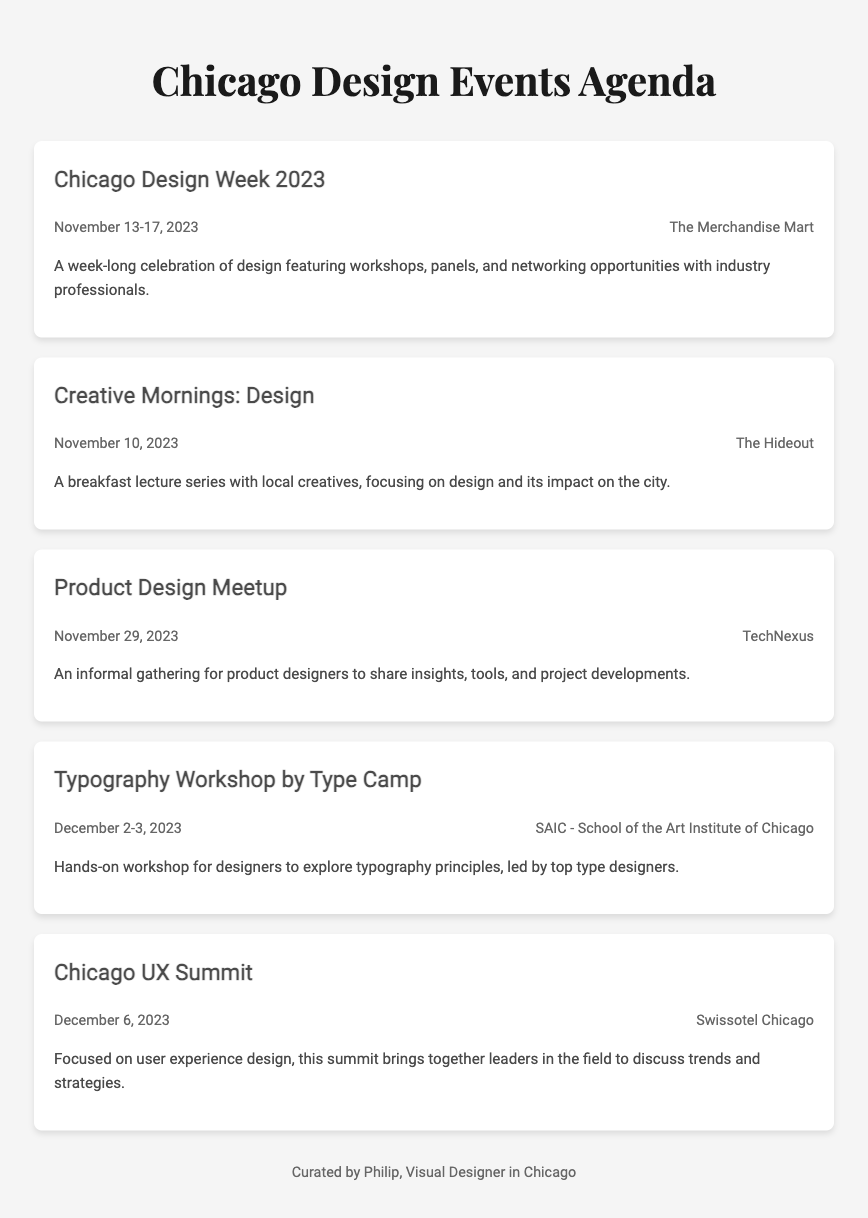What is the date range for Chicago Design Week 2023? Chicago Design Week 2023 occurs from November 13 to November 17, 2023, as stated in the event details.
Answer: November 13-17, 2023 Where is the Typography Workshop by Type Camp held? The venue for the Typography Workshop is mentioned as the School of the Art Institute of Chicago in the event description.
Answer: SAIC - School of the Art Institute of Chicago How many events are listed in the document? The document lists a total of five design events, specifically enumerating them in individual sections.
Answer: 5 What type of event is the Creative Mornings: Design? The event is described as a breakfast lecture series focusing on design, therefore it's categorized as an educational gathering.
Answer: Breakfast lecture series Which venue hosts the Chicago UX Summit? The venue for the Chicago UX Summit is specified as Swissotel Chicago within the document.
Answer: Swissotel Chicago What is the main focus of the Chicago UX Summit? The purpose of the Chicago UX Summit is stated as a focus on user experience design and discussions of trends and strategies.
Answer: User experience design On what date is the Product Design Meetup scheduled? The date for the Product Design Meetup is clearly stated as November 29, 2023, in the event details.
Answer: November 29, 2023 Who curated the agenda document? The footer credits Philip as the designer who curated the agenda, indicating his involvement in the document creation.
Answer: Philip 